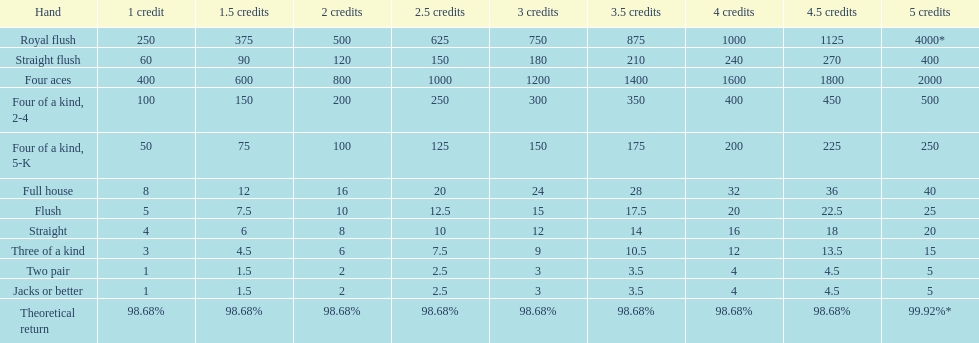How many credits must be spent to obtain a minimum payout of 2000 when possessing four aces? 5 credits. 